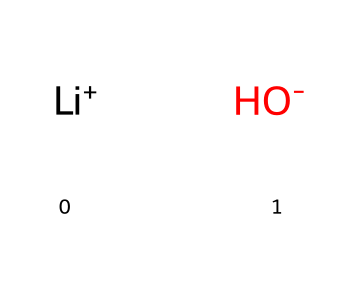What is the molecular formula of lithium hydroxide? The SMILES representation breaks down into lithium (Li) and hydroxide (OH). Combined, these give the formula LiOH.
Answer: LiOH How many total atoms are present in lithium hydroxide? The chemical consists of one lithium atom (Li) and one hydroxide group (OH) which contains two atoms (one oxygen and one hydrogen). Therefore, there are 3 atoms overall: 1 Li, 1 O, and 1 H.
Answer: 3 What type of compound is lithium hydroxide? Lithium hydroxide consists of a metal ion (Li+) and a hydroxide ion (OH-), categorizing it as a base.
Answer: base What charge does the lithium ion carry in lithium hydroxide? In the chemical notation, lithium is presented as [Li+], indicating it has a positive charge.
Answer: positive What a common use of lithium hydroxide in the energy sector? Lithium hydroxide is primarily used in lithium-ion batteries, contributing to effective energy storage in sustainable technologies.
Answer: batteries What characteristic property of lithium hydroxide allows it to neutralize acids? The presence of the hydroxide ion (OH-) is responsible for the alkaline nature of lithium hydroxide, enabling it to act as a neutralizer for acids.
Answer: alkaline 